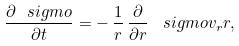Convert formula to latex. <formula><loc_0><loc_0><loc_500><loc_500>\frac { \partial \ s i g m o } { \partial t } = - \, \frac { 1 } { r } \, \frac { \partial } { \partial r } \, \ s i g m o v _ { r } r ,</formula> 